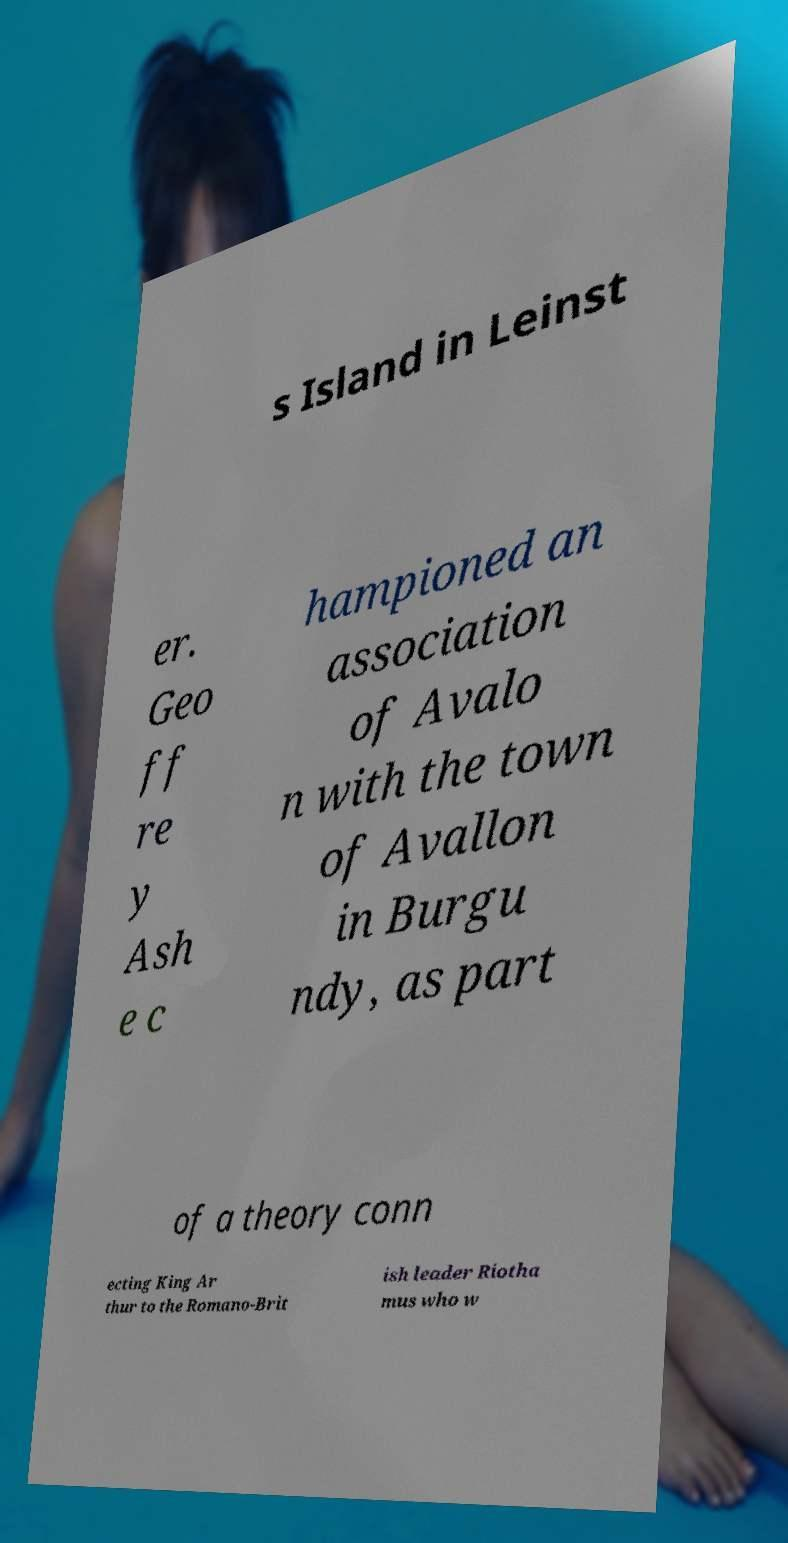Can you accurately transcribe the text from the provided image for me? s Island in Leinst er. Geo ff re y Ash e c hampioned an association of Avalo n with the town of Avallon in Burgu ndy, as part of a theory conn ecting King Ar thur to the Romano-Brit ish leader Riotha mus who w 